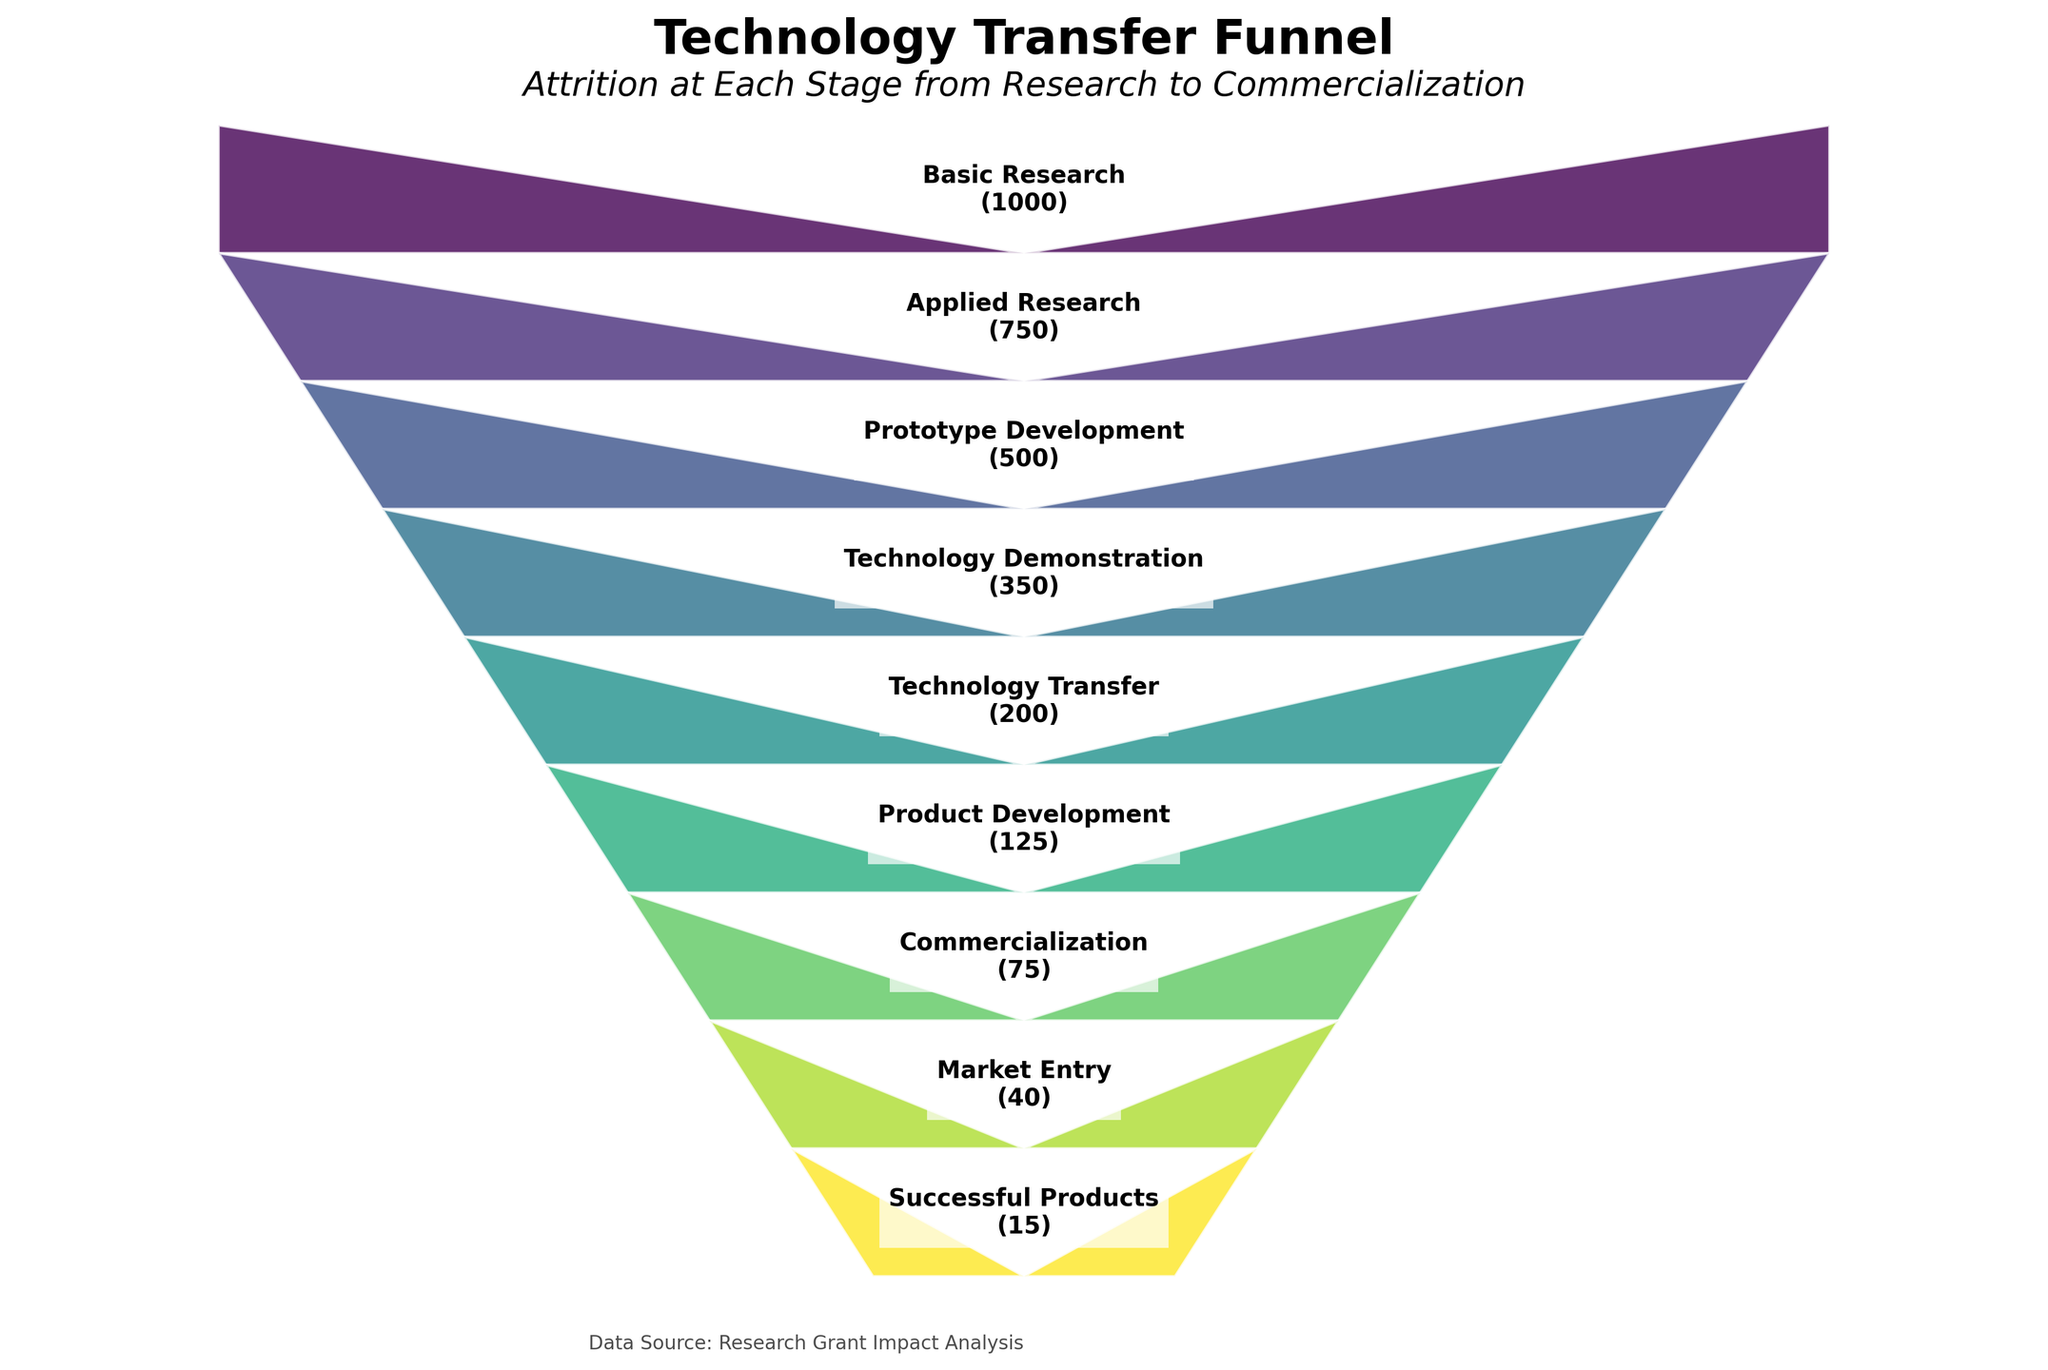what is the title of the figure? The title is displayed at the top of the figure. It reads "Technology Transfer Funnel."
Answer: Technology Transfer Funnel How many stages are there in the technology transfer funnel? By counting the number of labeled sections in the figure, we can see there are 9 stages in total.
Answer: 9 What stage has the highest number of projects? The highest number of projects is at the top of the funnel, labeled "Basic Research" with a value indicated directly next to it.
Answer: Basic Research By how much does the number of projects decrease from Basic Research to Applied Research? Subtract the number of projects in Applied Research from the number in Basic Research. That's 1000 - 750, which equals 250.
Answer: 250 What is the stage with the lowest number of projects? The lowest number of projects is at the bottom of the funnel, labeled "Successful Products" with a value indicated directly next to it.
Answer: Successful Products How many projects reach the Commercialization stage? Identify the section labeled "Commercialization." The number of projects in this stage is listed as 75.
Answer: 75 Compare the number of projects between Prototype Development and Market Entry. Which stage has more projects? Prototype Development has 500 projects while Market Entry has 40 projects. Thus, Prototype Development has more projects than Market Entry.
Answer: Prototype Development What percentage of projects progress from Technology Demonstration to Technology Transfer? The number of projects at Technology Demonstration is 350, and at Technology Transfer is 200. The percentage is calculated as (200 / 350) * 100%.
Answer: 57.14% What is the attrition rate from Product Development to Successful Products? The number of projects at Product Development is 125, and the number at Successful Products is 15. The attrition rate is calculated as [(125 - 15) / 125] * 100%.
Answer: 88% What stages form the middle of the funnel? The middle stages of the funnel are those that appear after the initial and before the final stages. These stages are Prototype Development, Technology Demonstration, Technology Transfer, and Product Development.
Answer: Prototype Development, Technology Demonstration, Technology Transfer, Product Development 